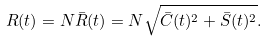Convert formula to latex. <formula><loc_0><loc_0><loc_500><loc_500>R ( t ) = N \bar { R } ( t ) = N \sqrt { \bar { C } ( t ) ^ { 2 } + \bar { S } ( t ) ^ { 2 } } .</formula> 